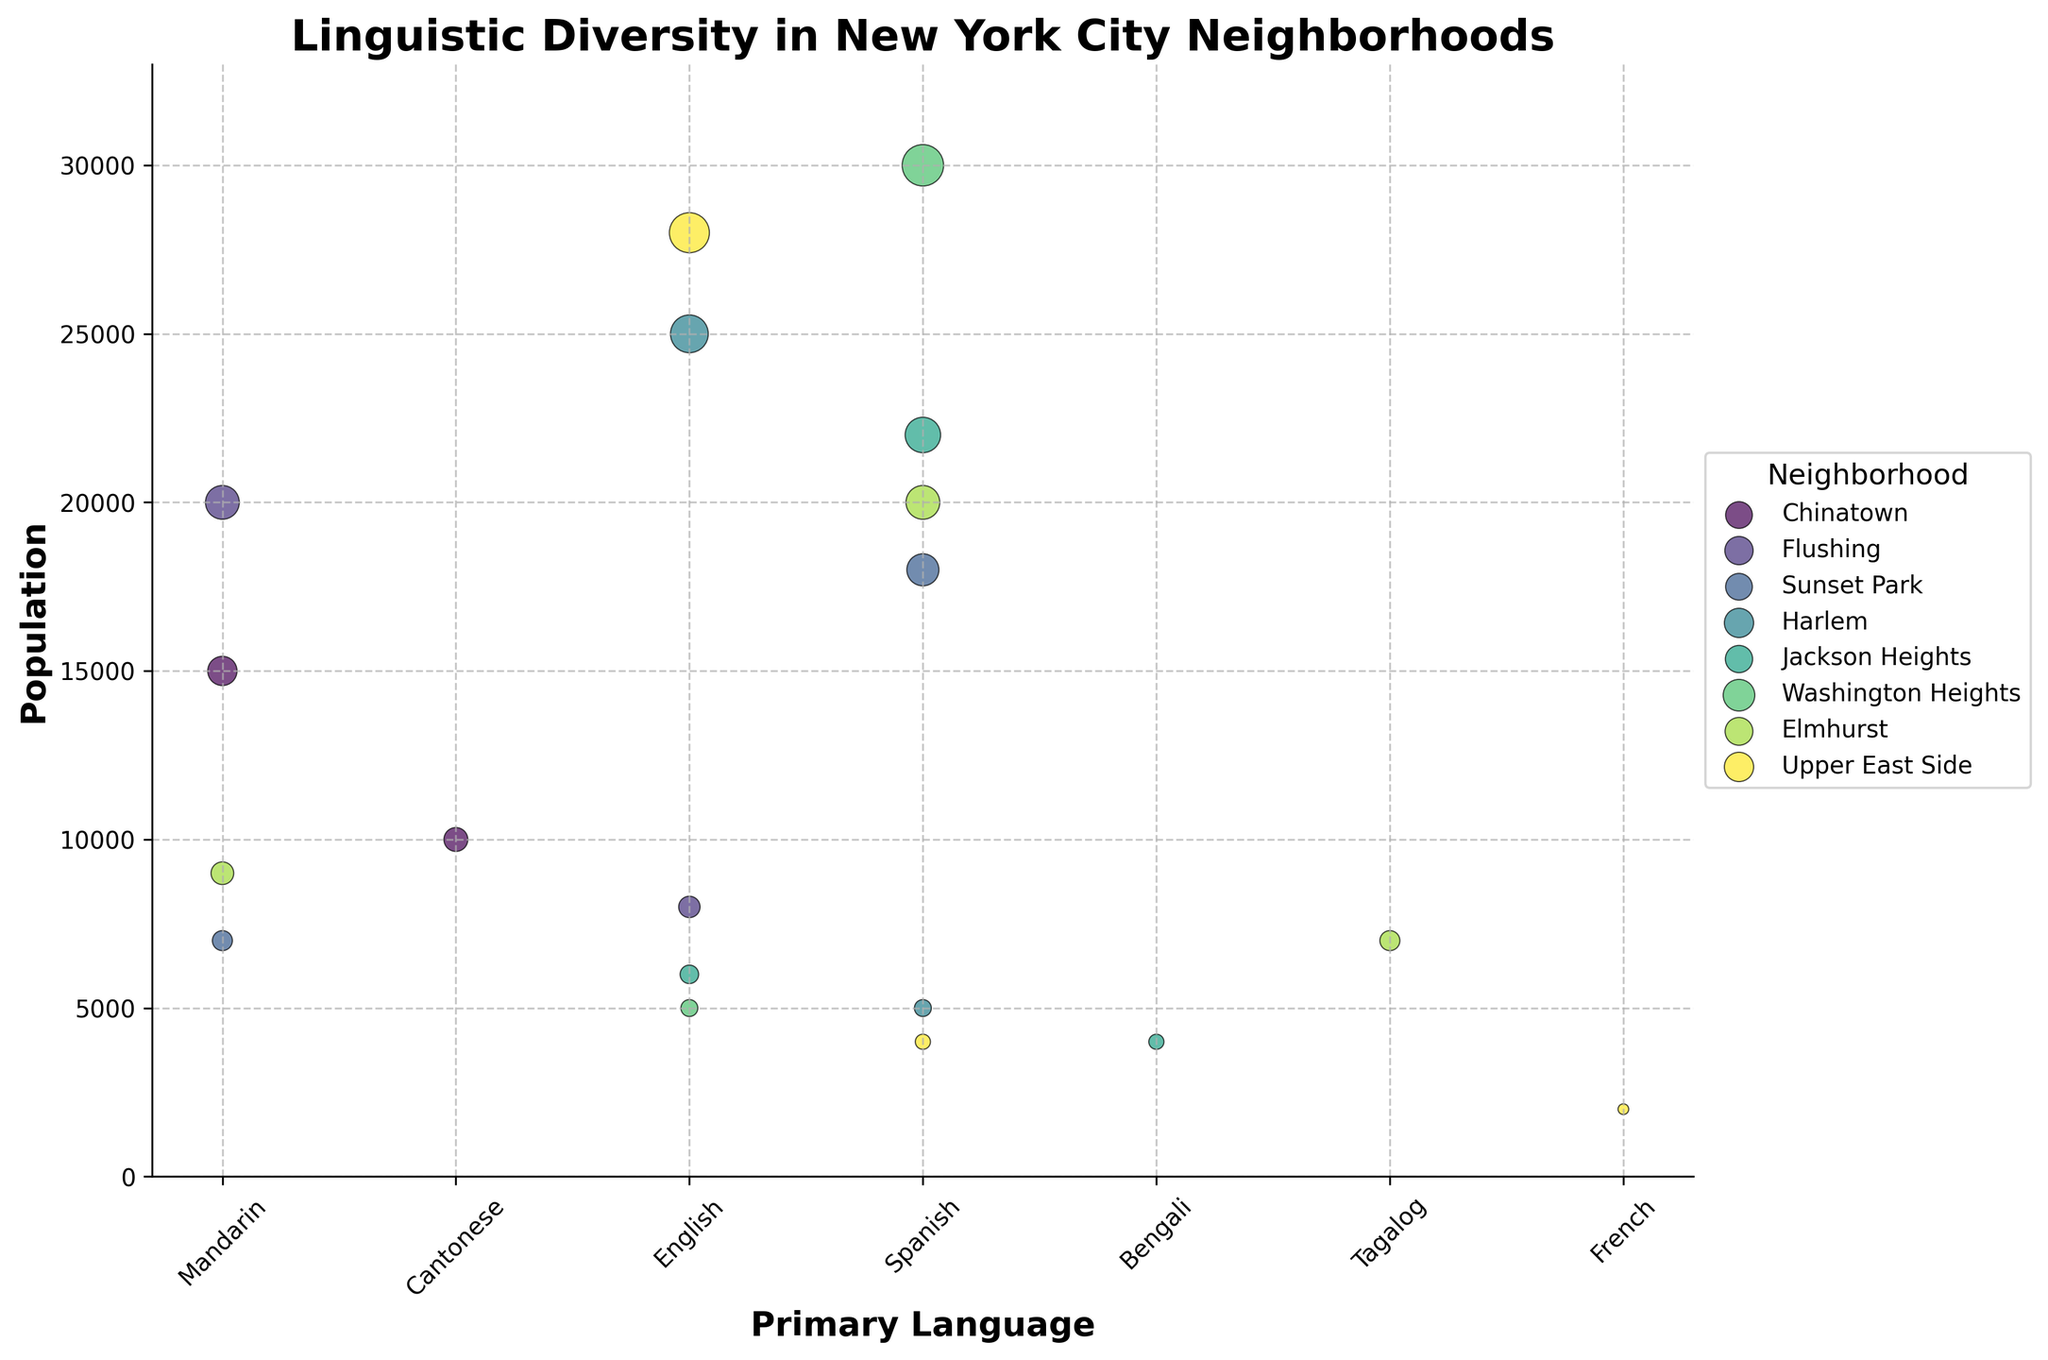Which neighborhood has the highest population speaking Spanish? To determine this, look at the Spanish-speaking population in each neighborhood and identify the largest value. Washington Heights has 30,000 Spanish speakers, which is the highest.
Answer: Washington Heights Which primary language has the highest population in Chinatown? Evaluate the population values for each primary language in Chinatown. Mandarin has 15,000 speakers, while Cantonese has 10,000. Thus, Mandarin has the highest population.
Answer: Mandarin Comparing Sunset Park and Elmhurst, which neighborhood has a larger population of Mandarin speakers? Check the population for Mandarin speakers in both neighborhoods. Sunset Park has 7,000 while Elmhurst has 9,000. Elmhurst has the larger population.
Answer: Elmhurst What is the total population speaking English in Harlem and Jackson Heights combined? Add the English-speaking population of Harlem (25,000) and Jackson Heights (6,000). The total is 25,000 + 6,000 = 31,000.
Answer: 31,000 Which neighborhood has the smallest representation of a primary language, and what is that language? Look for the smallest population values in the dataset; the French-speaking population in Upper East Side is 2,000, which is the smallest.
Answer: Upper East Side, French 